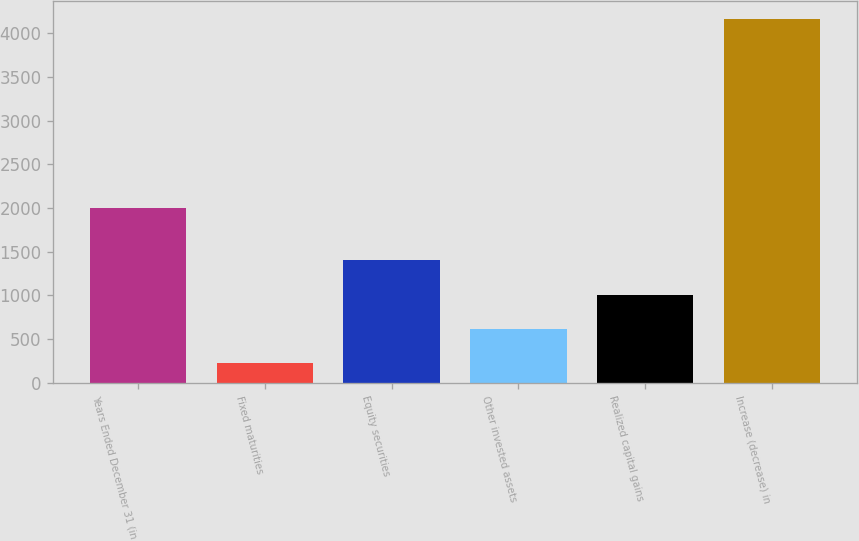<chart> <loc_0><loc_0><loc_500><loc_500><bar_chart><fcel>Years Ended December 31 (in<fcel>Fixed maturities<fcel>Equity securities<fcel>Other invested assets<fcel>Realized capital gains<fcel>Increase (decrease) in<nl><fcel>2003<fcel>222<fcel>1403.1<fcel>615.7<fcel>1009.4<fcel>4159<nl></chart> 